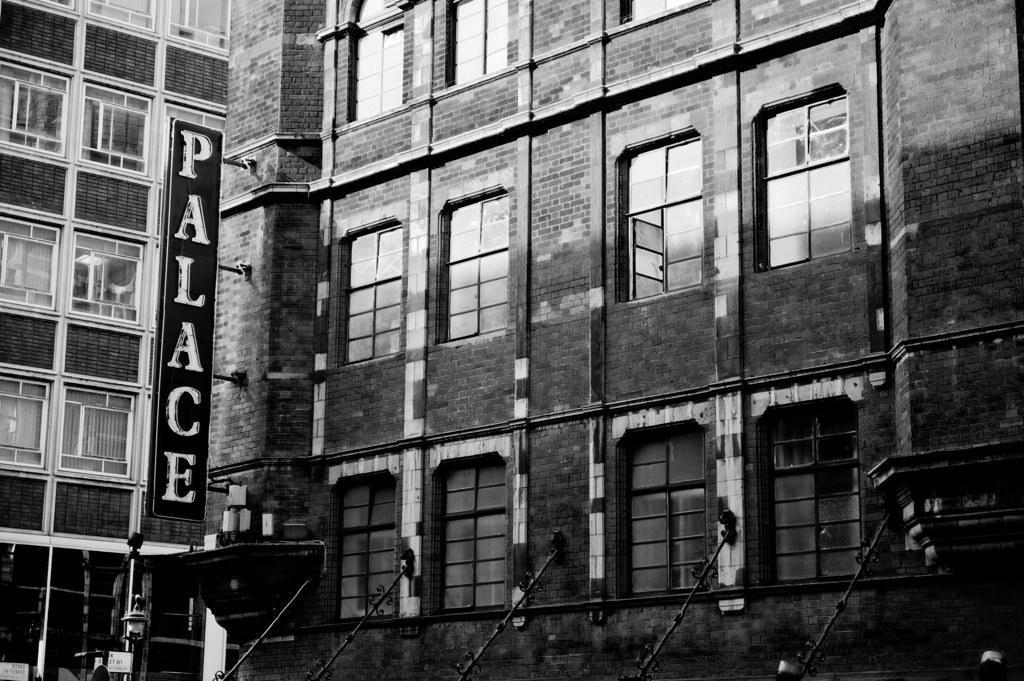In one or two sentences, can you explain what this image depicts? In this black and white image, we can see a building. There is a board on the left side of the image. 